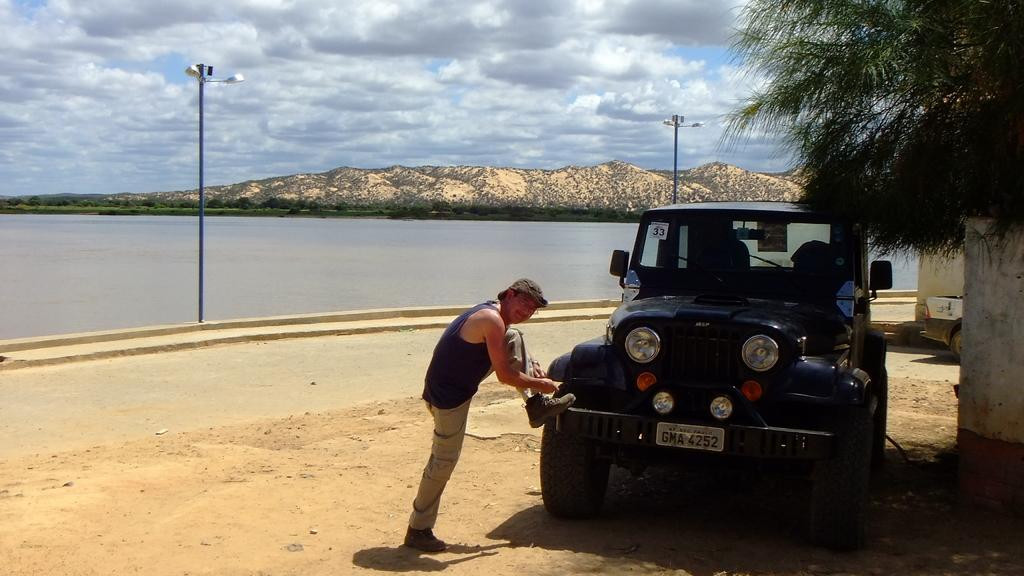Who is the main subject in the image? There is a man in the middle of the image. What is in front of the man? There is a vehicle and a tree in front of the man. What can be seen in the background of the image? In the background of the image, there are poles, water, hills, more trees, and clouds. Where is the library located in the image? There is no library present in the image. Can you see any cobwebs in the image? There are no cobwebs visible in the image. 